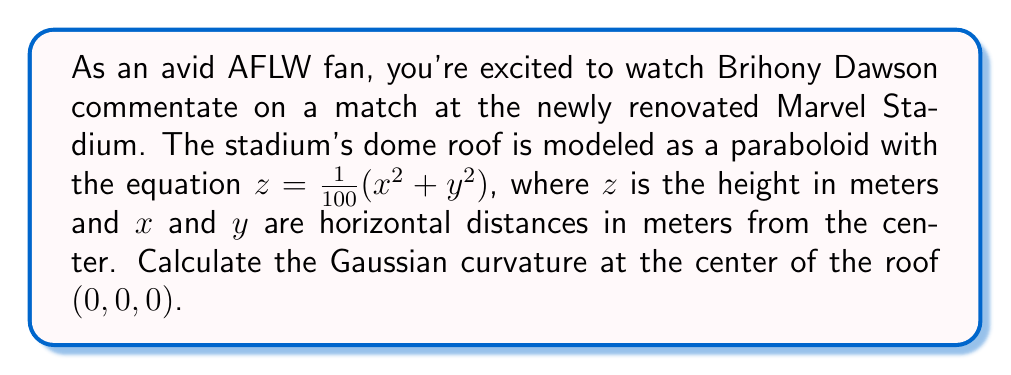Solve this math problem. To find the Gaussian curvature of the paraboloid roof, we'll follow these steps:

1) The surface is given by $z = f(x,y) = \frac{1}{100}(x^2 + y^2)$

2) Calculate the partial derivatives:
   $f_x = \frac{\partial f}{\partial x} = \frac{1}{50}x$
   $f_y = \frac{\partial f}{\partial y} = \frac{1}{50}y$
   $f_{xx} = \frac{\partial^2 f}{\partial x^2} = \frac{1}{50}$
   $f_{yy} = \frac{\partial^2 f}{\partial y^2} = \frac{1}{50}$
   $f_{xy} = \frac{\partial^2 f}{\partial x \partial y} = 0$

3) The Gaussian curvature K is given by:
   $$K = \frac{f_{xx}f_{yy} - f_{xy}^2}{(1 + f_x^2 + f_y^2)^2}$$

4) At the center point (0, 0, 0):
   $f_x = f_y = 0$
   $f_{xx} = f_{yy} = \frac{1}{50}$
   $f_{xy} = 0$

5) Substituting these values:
   $$K = \frac{(\frac{1}{50})(\frac{1}{50}) - 0^2}{(1 + 0^2 + 0^2)^2} = \frac{1}{2500}$$

Therefore, the Gaussian curvature at the center of the roof is $\frac{1}{2500}$ m^(-2).
Answer: $\frac{1}{2500}$ m^(-2) 